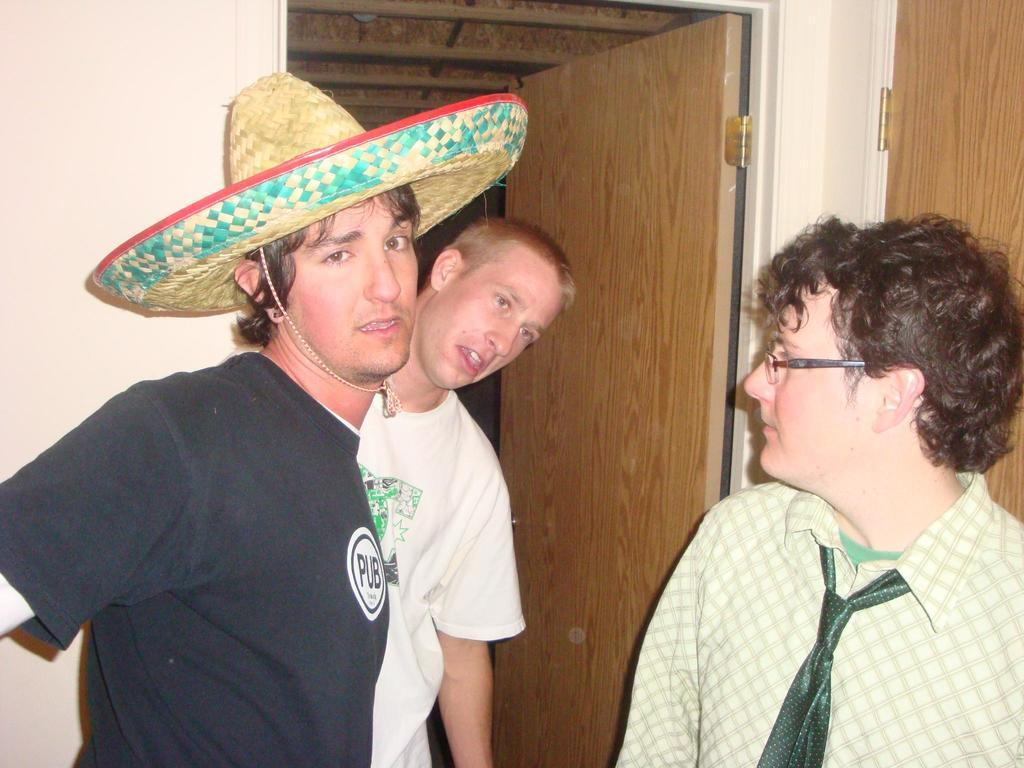How many people are in the image? There are three persons standing in the image. Can you describe the clothing of the first person? One person is wearing a black shirt and a hat. What accessories can be seen on the second person? Another person is wearing spectacles and a tie. What can be seen in the background of the image? There is a door visible in the background of the image. What type of magic is being performed by the person wearing a hat in the image? There is no indication of magic being performed in the image; the person is simply wearing a hat and standing with two other individuals. 